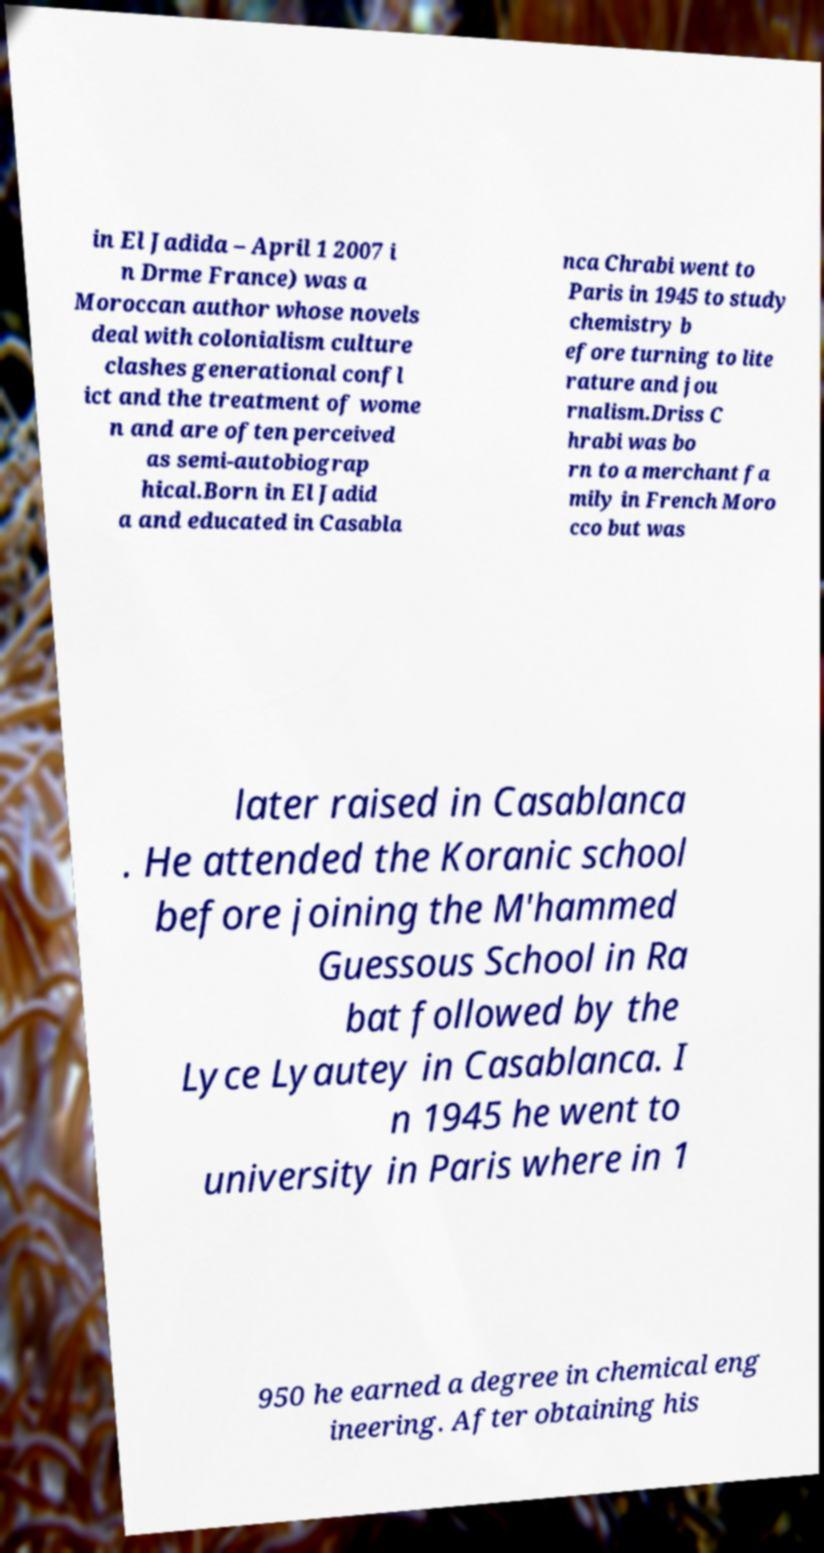Please identify and transcribe the text found in this image. in El Jadida – April 1 2007 i n Drme France) was a Moroccan author whose novels deal with colonialism culture clashes generational confl ict and the treatment of wome n and are often perceived as semi-autobiograp hical.Born in El Jadid a and educated in Casabla nca Chrabi went to Paris in 1945 to study chemistry b efore turning to lite rature and jou rnalism.Driss C hrabi was bo rn to a merchant fa mily in French Moro cco but was later raised in Casablanca . He attended the Koranic school before joining the M'hammed Guessous School in Ra bat followed by the Lyce Lyautey in Casablanca. I n 1945 he went to university in Paris where in 1 950 he earned a degree in chemical eng ineering. After obtaining his 